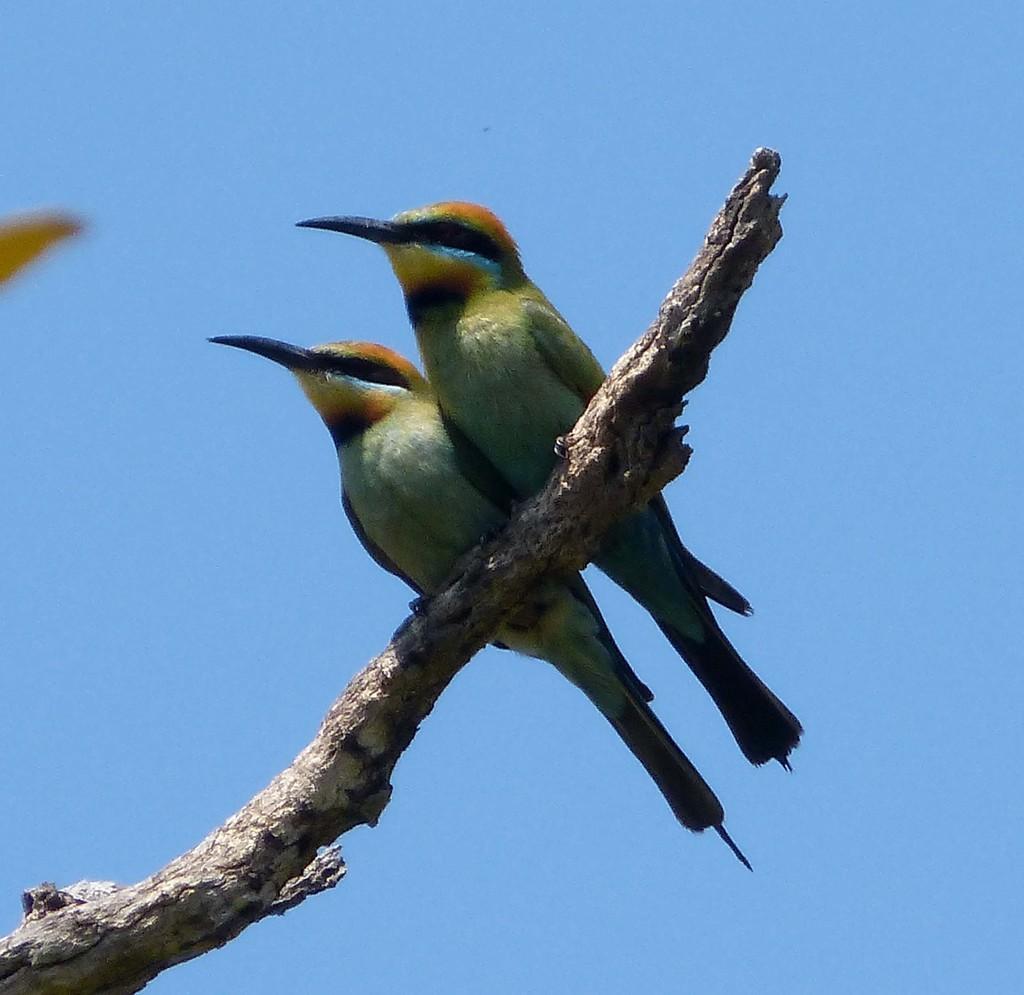Can you describe this image briefly? In this image, I can see two birds standing on the wooden branch. This is the sky. 